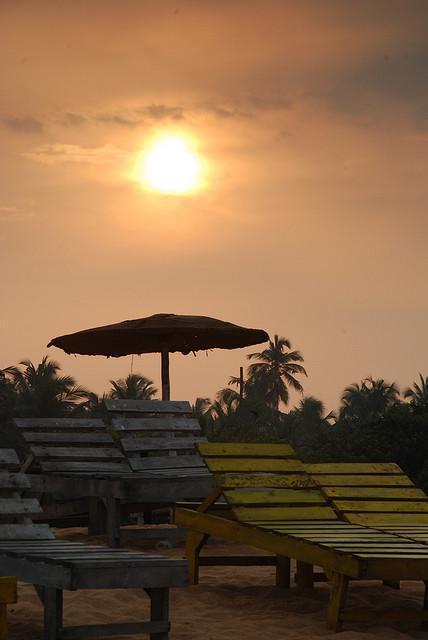How many chairs are there?
Give a very brief answer. 5. How many people are jumping on a skateboard?
Give a very brief answer. 0. 